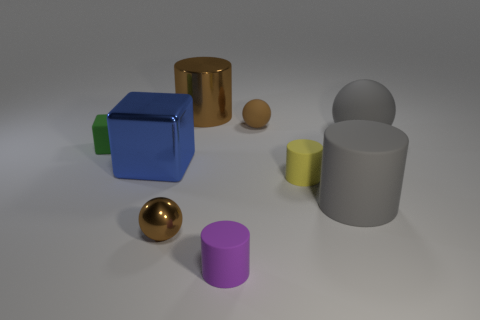Subtract all purple blocks. Subtract all blue cylinders. How many blocks are left? 2 Add 1 big cubes. How many objects exist? 10 Subtract all blocks. How many objects are left? 7 Subtract 0 gray cubes. How many objects are left? 9 Subtract all large gray matte spheres. Subtract all large brown cylinders. How many objects are left? 7 Add 4 spheres. How many spheres are left? 7 Add 5 green rubber blocks. How many green rubber blocks exist? 6 